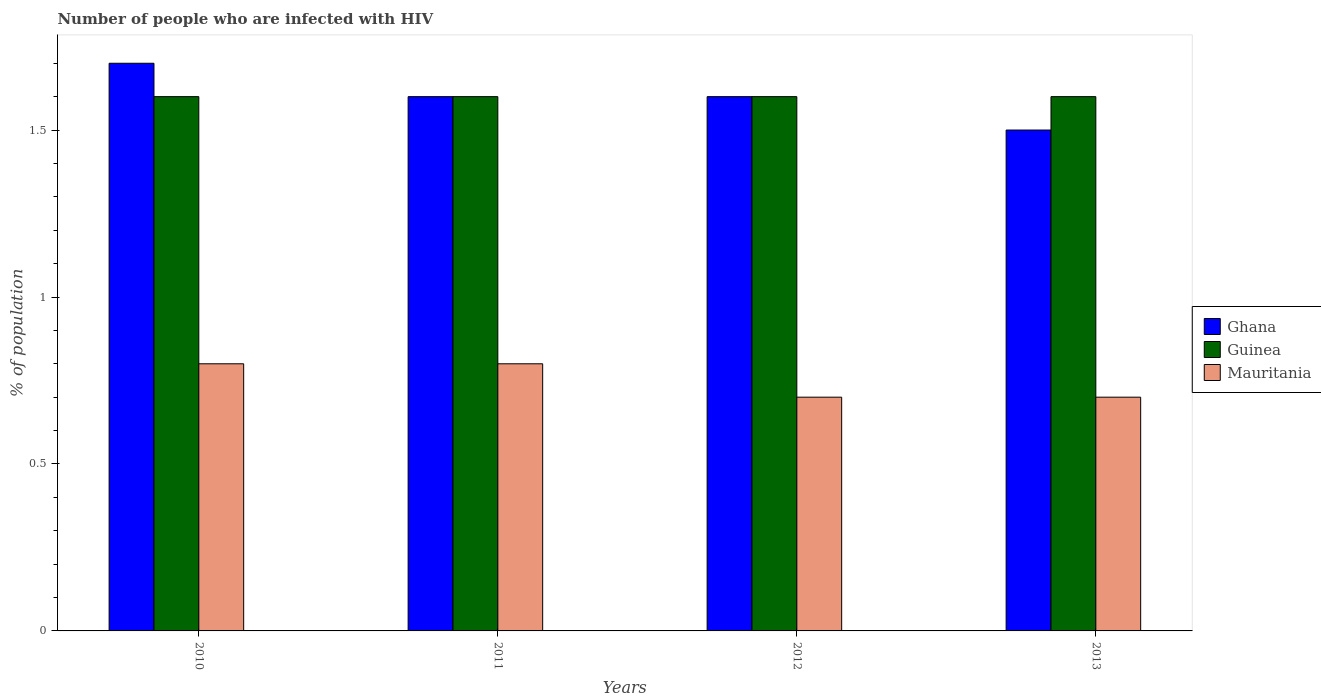Are the number of bars on each tick of the X-axis equal?
Make the answer very short. Yes. How many bars are there on the 3rd tick from the left?
Your answer should be compact. 3. How many bars are there on the 3rd tick from the right?
Make the answer very short. 3. What is the percentage of HIV infected population in in Mauritania in 2013?
Keep it short and to the point. 0.7. In which year was the percentage of HIV infected population in in Mauritania maximum?
Offer a terse response. 2010. In which year was the percentage of HIV infected population in in Ghana minimum?
Your response must be concise. 2013. What is the difference between the percentage of HIV infected population in in Guinea in 2012 and that in 2013?
Offer a terse response. 0. What is the difference between the percentage of HIV infected population in in Guinea in 2011 and the percentage of HIV infected population in in Mauritania in 2012?
Your answer should be compact. 0.9. What is the average percentage of HIV infected population in in Guinea per year?
Provide a succinct answer. 1.6. In the year 2012, what is the difference between the percentage of HIV infected population in in Ghana and percentage of HIV infected population in in Guinea?
Keep it short and to the point. 0. Is the percentage of HIV infected population in in Mauritania in 2010 less than that in 2013?
Provide a succinct answer. No. Is the difference between the percentage of HIV infected population in in Ghana in 2011 and 2012 greater than the difference between the percentage of HIV infected population in in Guinea in 2011 and 2012?
Your answer should be compact. No. What is the difference between the highest and the second highest percentage of HIV infected population in in Ghana?
Make the answer very short. 0.1. What is the difference between the highest and the lowest percentage of HIV infected population in in Ghana?
Make the answer very short. 0.2. In how many years, is the percentage of HIV infected population in in Mauritania greater than the average percentage of HIV infected population in in Mauritania taken over all years?
Your response must be concise. 2. What does the 2nd bar from the left in 2012 represents?
Your answer should be compact. Guinea. Are all the bars in the graph horizontal?
Offer a terse response. No. What is the difference between two consecutive major ticks on the Y-axis?
Offer a very short reply. 0.5. Does the graph contain grids?
Offer a terse response. No. How many legend labels are there?
Keep it short and to the point. 3. How are the legend labels stacked?
Give a very brief answer. Vertical. What is the title of the graph?
Your answer should be very brief. Number of people who are infected with HIV. Does "Comoros" appear as one of the legend labels in the graph?
Provide a short and direct response. No. What is the label or title of the X-axis?
Provide a succinct answer. Years. What is the label or title of the Y-axis?
Keep it short and to the point. % of population. What is the % of population of Guinea in 2010?
Keep it short and to the point. 1.6. What is the % of population of Mauritania in 2010?
Provide a succinct answer. 0.8. What is the % of population of Mauritania in 2011?
Your answer should be compact. 0.8. What is the % of population of Guinea in 2012?
Offer a very short reply. 1.6. What is the % of population in Guinea in 2013?
Keep it short and to the point. 1.6. Across all years, what is the minimum % of population of Mauritania?
Give a very brief answer. 0.7. What is the total % of population in Mauritania in the graph?
Your answer should be compact. 3. What is the difference between the % of population in Guinea in 2010 and that in 2011?
Provide a succinct answer. 0. What is the difference between the % of population in Ghana in 2010 and that in 2012?
Offer a very short reply. 0.1. What is the difference between the % of population in Ghana in 2010 and that in 2013?
Provide a succinct answer. 0.2. What is the difference between the % of population in Mauritania in 2010 and that in 2013?
Your response must be concise. 0.1. What is the difference between the % of population of Ghana in 2011 and that in 2012?
Your answer should be compact. 0. What is the difference between the % of population in Mauritania in 2011 and that in 2013?
Your answer should be compact. 0.1. What is the difference between the % of population in Guinea in 2012 and that in 2013?
Your response must be concise. 0. What is the difference between the % of population in Ghana in 2010 and the % of population in Guinea in 2011?
Provide a succinct answer. 0.1. What is the difference between the % of population of Ghana in 2010 and the % of population of Mauritania in 2011?
Offer a very short reply. 0.9. What is the difference between the % of population in Ghana in 2010 and the % of population in Mauritania in 2012?
Provide a short and direct response. 1. What is the difference between the % of population of Ghana in 2010 and the % of population of Guinea in 2013?
Keep it short and to the point. 0.1. What is the difference between the % of population in Ghana in 2011 and the % of population in Guinea in 2013?
Provide a succinct answer. 0. What is the difference between the % of population of Guinea in 2011 and the % of population of Mauritania in 2013?
Your answer should be very brief. 0.9. What is the difference between the % of population of Ghana in 2012 and the % of population of Guinea in 2013?
Keep it short and to the point. 0. What is the difference between the % of population in Ghana in 2012 and the % of population in Mauritania in 2013?
Provide a succinct answer. 0.9. What is the difference between the % of population in Guinea in 2012 and the % of population in Mauritania in 2013?
Ensure brevity in your answer.  0.9. What is the average % of population of Ghana per year?
Offer a terse response. 1.6. What is the average % of population of Mauritania per year?
Your answer should be very brief. 0.75. In the year 2010, what is the difference between the % of population in Guinea and % of population in Mauritania?
Ensure brevity in your answer.  0.8. In the year 2011, what is the difference between the % of population of Guinea and % of population of Mauritania?
Your answer should be compact. 0.8. In the year 2012, what is the difference between the % of population in Ghana and % of population in Mauritania?
Make the answer very short. 0.9. In the year 2013, what is the difference between the % of population in Guinea and % of population in Mauritania?
Make the answer very short. 0.9. What is the ratio of the % of population of Ghana in 2010 to that in 2011?
Provide a succinct answer. 1.06. What is the ratio of the % of population in Mauritania in 2010 to that in 2011?
Make the answer very short. 1. What is the ratio of the % of population of Ghana in 2010 to that in 2012?
Provide a short and direct response. 1.06. What is the ratio of the % of population of Mauritania in 2010 to that in 2012?
Give a very brief answer. 1.14. What is the ratio of the % of population in Ghana in 2010 to that in 2013?
Offer a very short reply. 1.13. What is the ratio of the % of population in Guinea in 2010 to that in 2013?
Keep it short and to the point. 1. What is the ratio of the % of population of Mauritania in 2010 to that in 2013?
Provide a succinct answer. 1.14. What is the ratio of the % of population in Ghana in 2011 to that in 2013?
Provide a succinct answer. 1.07. What is the ratio of the % of population of Ghana in 2012 to that in 2013?
Offer a terse response. 1.07. What is the difference between the highest and the second highest % of population in Ghana?
Your answer should be compact. 0.1. What is the difference between the highest and the second highest % of population in Guinea?
Your answer should be very brief. 0. What is the difference between the highest and the second highest % of population in Mauritania?
Your response must be concise. 0. What is the difference between the highest and the lowest % of population of Ghana?
Keep it short and to the point. 0.2. What is the difference between the highest and the lowest % of population in Mauritania?
Offer a very short reply. 0.1. 